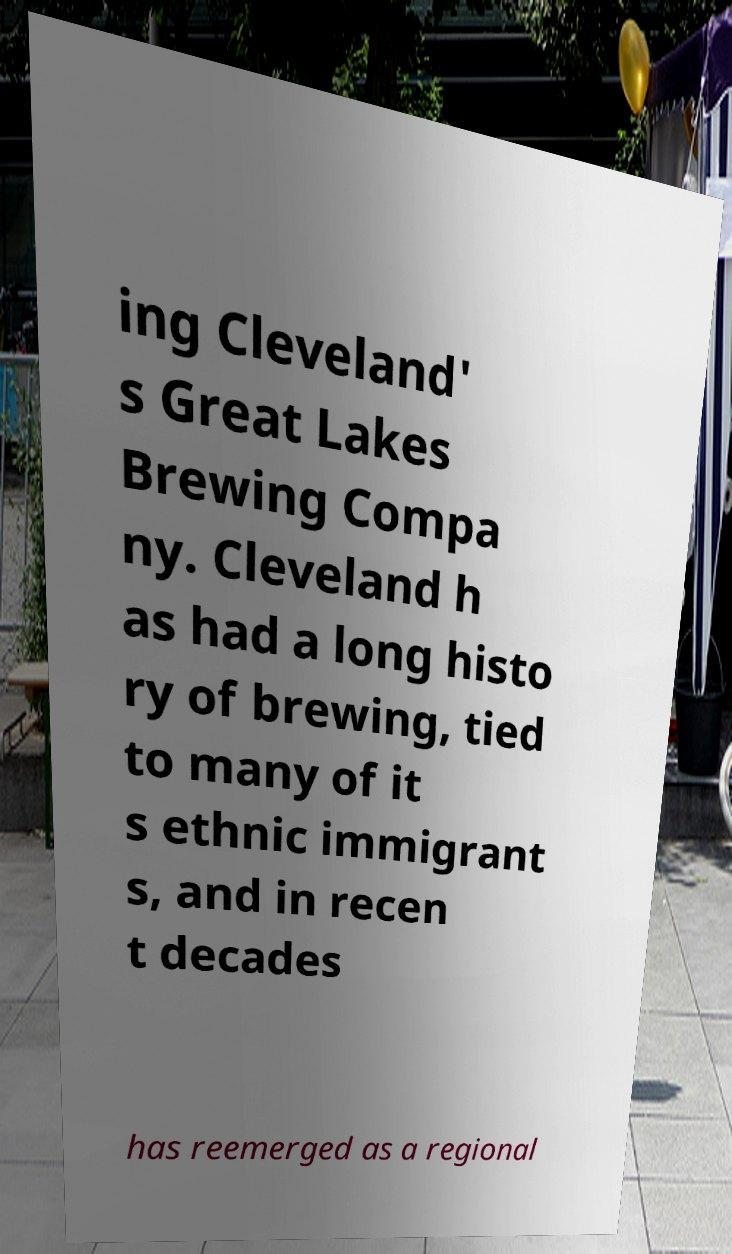Can you read and provide the text displayed in the image?This photo seems to have some interesting text. Can you extract and type it out for me? ing Cleveland' s Great Lakes Brewing Compa ny. Cleveland h as had a long histo ry of brewing, tied to many of it s ethnic immigrant s, and in recen t decades has reemerged as a regional 